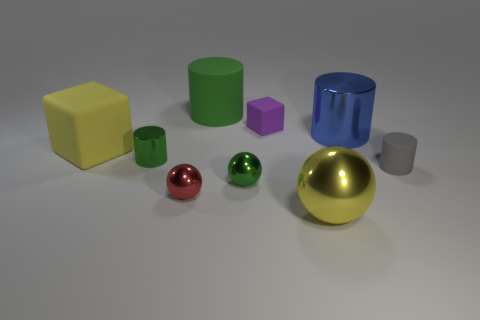Add 1 red matte blocks. How many objects exist? 10 Subtract all spheres. How many objects are left? 6 Add 6 big green objects. How many big green objects are left? 7 Add 6 blue cylinders. How many blue cylinders exist? 7 Subtract 0 blue balls. How many objects are left? 9 Subtract all tiny shiny spheres. Subtract all big objects. How many objects are left? 3 